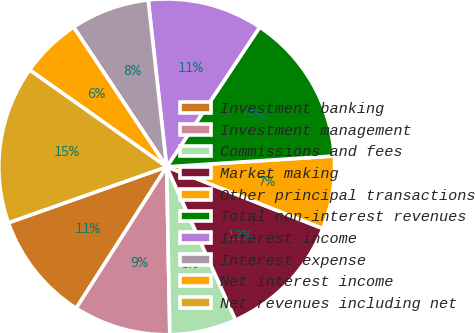Convert chart to OTSL. <chart><loc_0><loc_0><loc_500><loc_500><pie_chart><fcel>Investment banking<fcel>Investment management<fcel>Commissions and fees<fcel>Market making<fcel>Other principal transactions<fcel>Total non-interest revenues<fcel>Interest income<fcel>Interest expense<fcel>Net interest income<fcel>Net revenues including net<nl><fcel>10.53%<fcel>9.36%<fcel>6.43%<fcel>12.28%<fcel>7.02%<fcel>14.62%<fcel>11.11%<fcel>7.6%<fcel>5.85%<fcel>15.2%<nl></chart> 